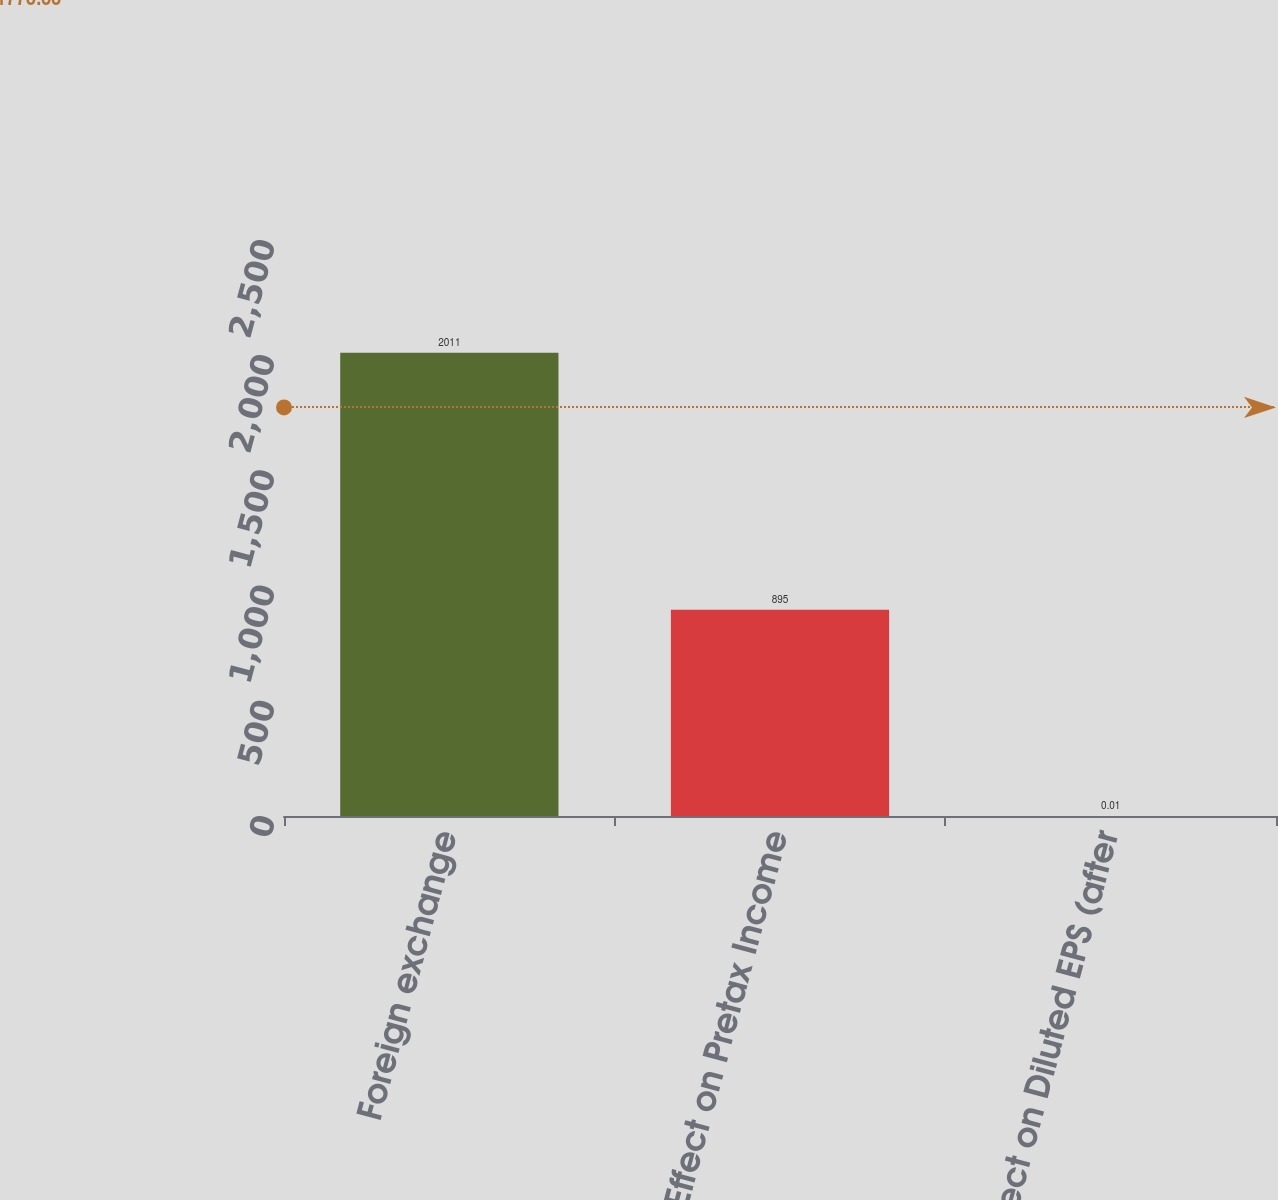Convert chart to OTSL. <chart><loc_0><loc_0><loc_500><loc_500><bar_chart><fcel>Foreign exchange<fcel>Effect on Pretax Income<fcel>Effect on Diluted EPS (after<nl><fcel>2011<fcel>895<fcel>0.01<nl></chart> 